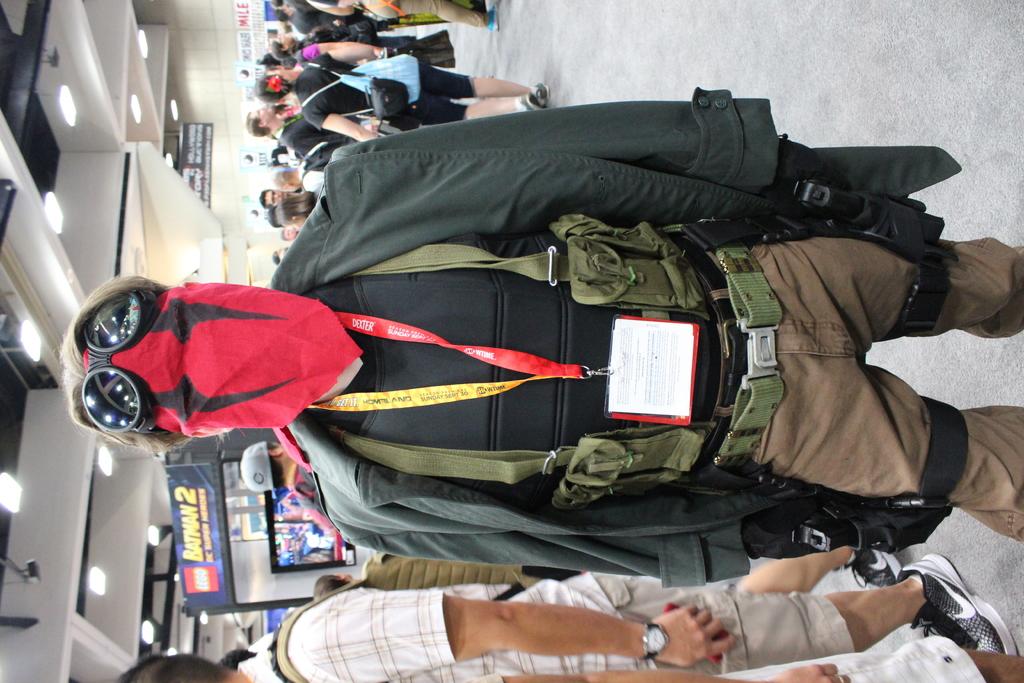What brand is seen behind the man's head?
Provide a short and direct response. Lego. 